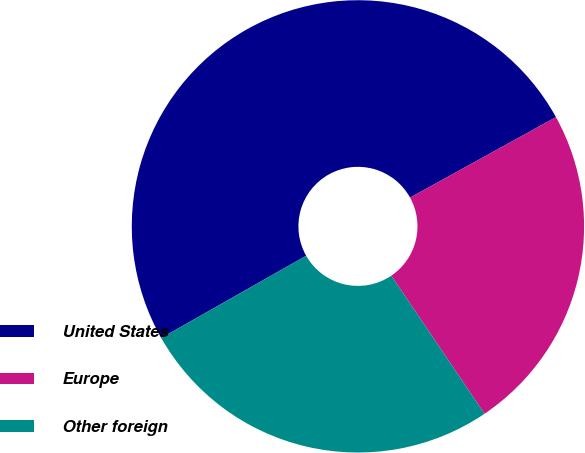Convert chart. <chart><loc_0><loc_0><loc_500><loc_500><pie_chart><fcel>United States<fcel>Europe<fcel>Other foreign<nl><fcel>50.19%<fcel>23.57%<fcel>26.24%<nl></chart> 